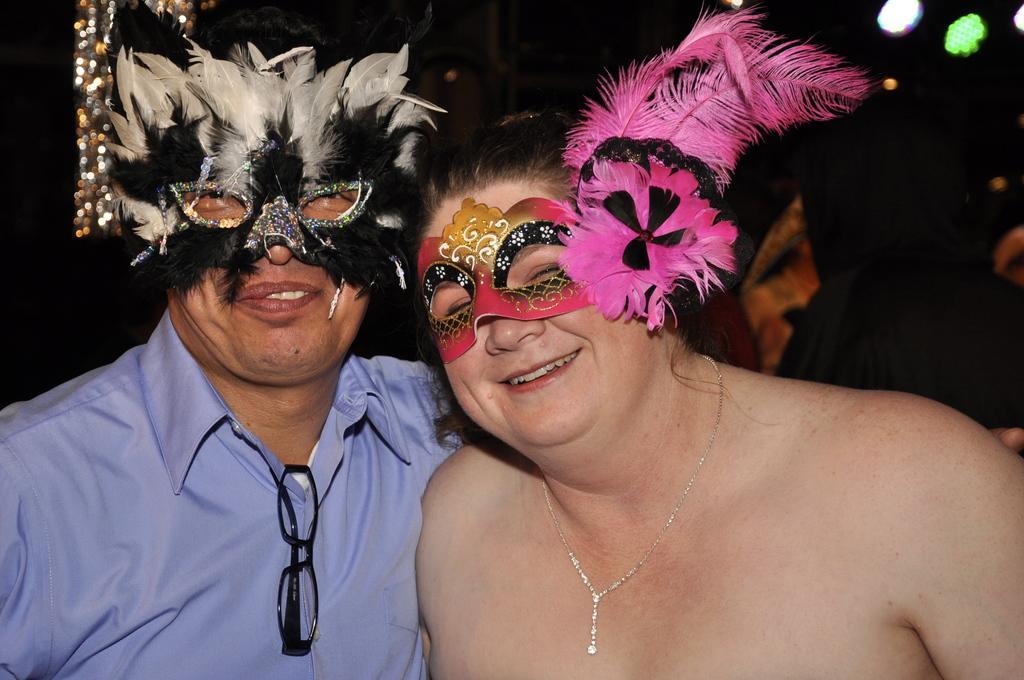Please provide a concise description of this image. In this picture there is a woman and a man wearing decorative eye mask, smiling and giving a pose into the camera. Behind there is a black background. 